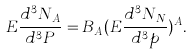Convert formula to latex. <formula><loc_0><loc_0><loc_500><loc_500>E \frac { d ^ { 3 } N _ { A } } { d ^ { 3 } P } = B _ { A } ( E \frac { d ^ { 3 } N _ { N } } { d ^ { 3 } p } ) ^ { A } .</formula> 